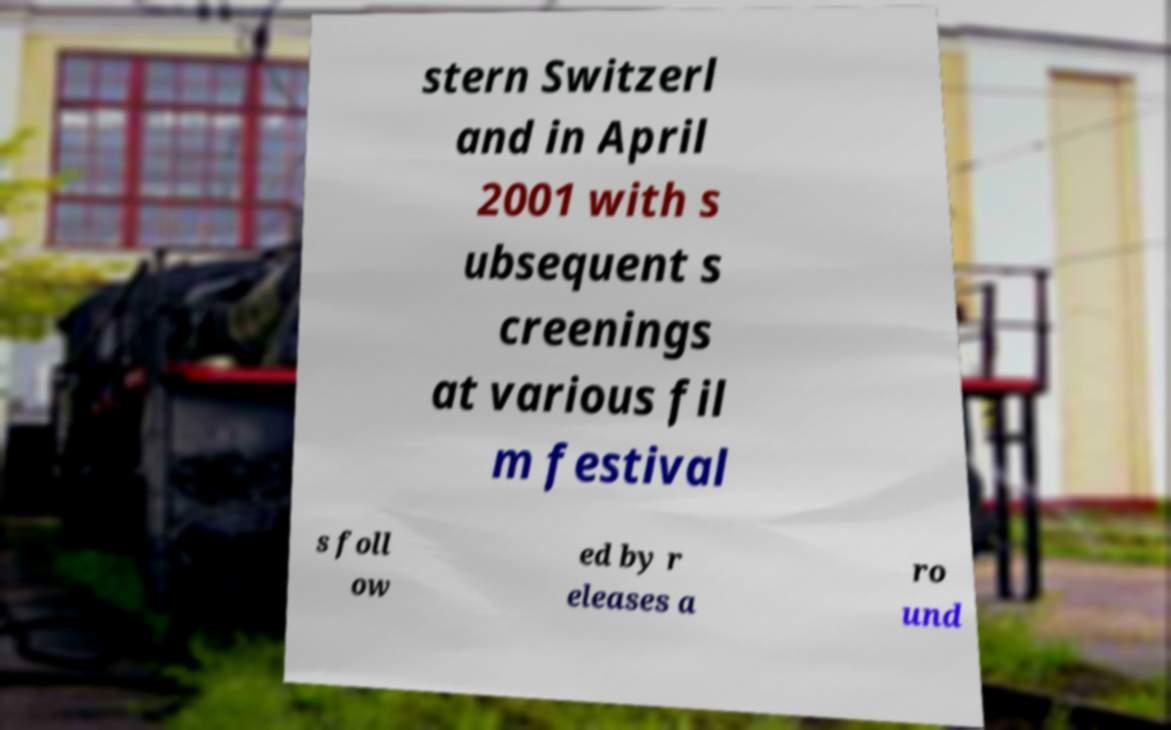I need the written content from this picture converted into text. Can you do that? stern Switzerl and in April 2001 with s ubsequent s creenings at various fil m festival s foll ow ed by r eleases a ro und 